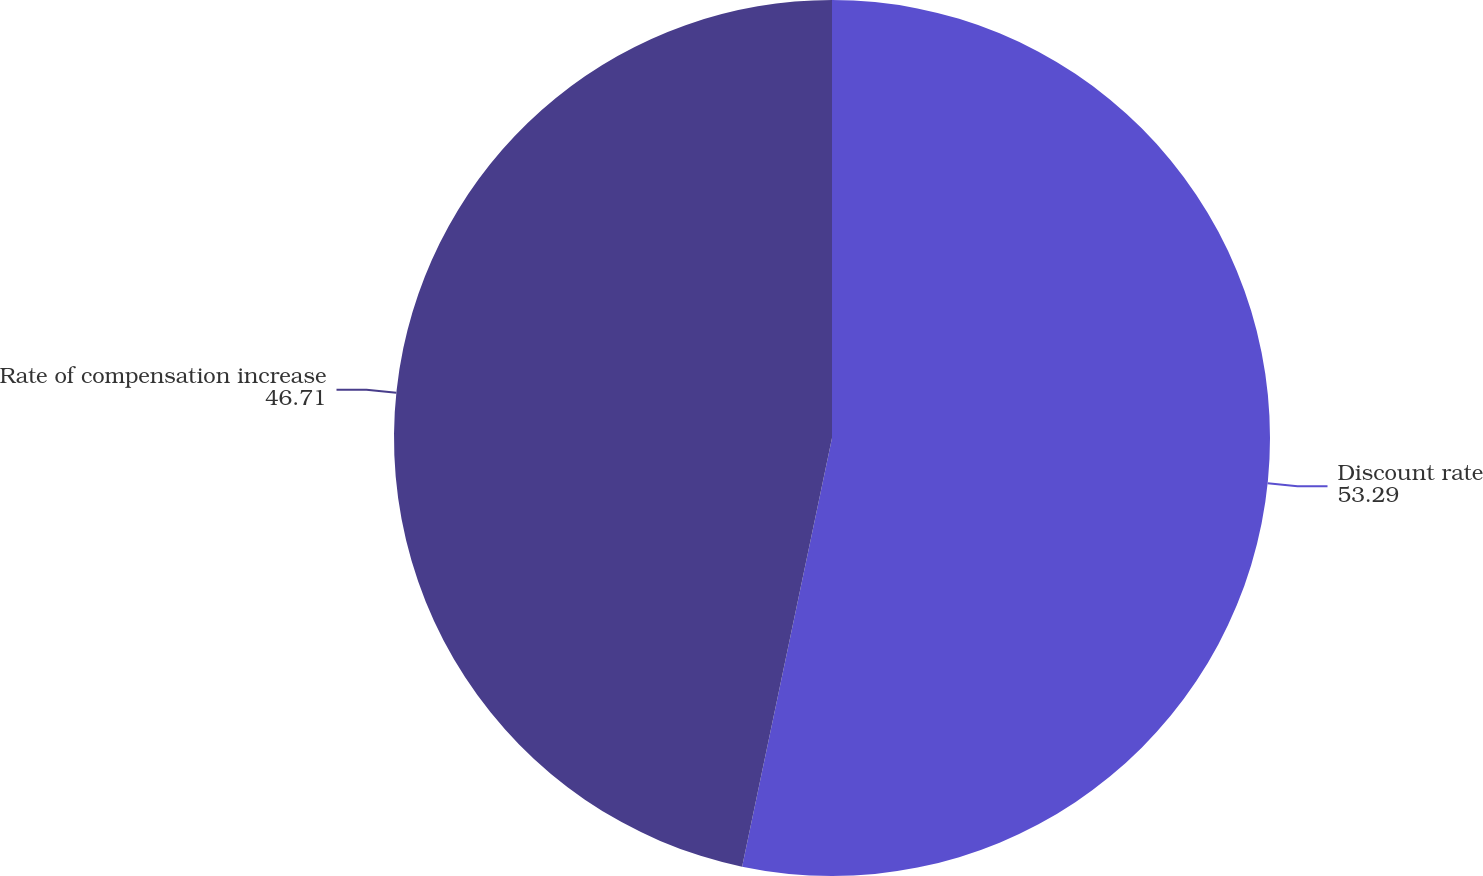<chart> <loc_0><loc_0><loc_500><loc_500><pie_chart><fcel>Discount rate<fcel>Rate of compensation increase<nl><fcel>53.29%<fcel>46.71%<nl></chart> 